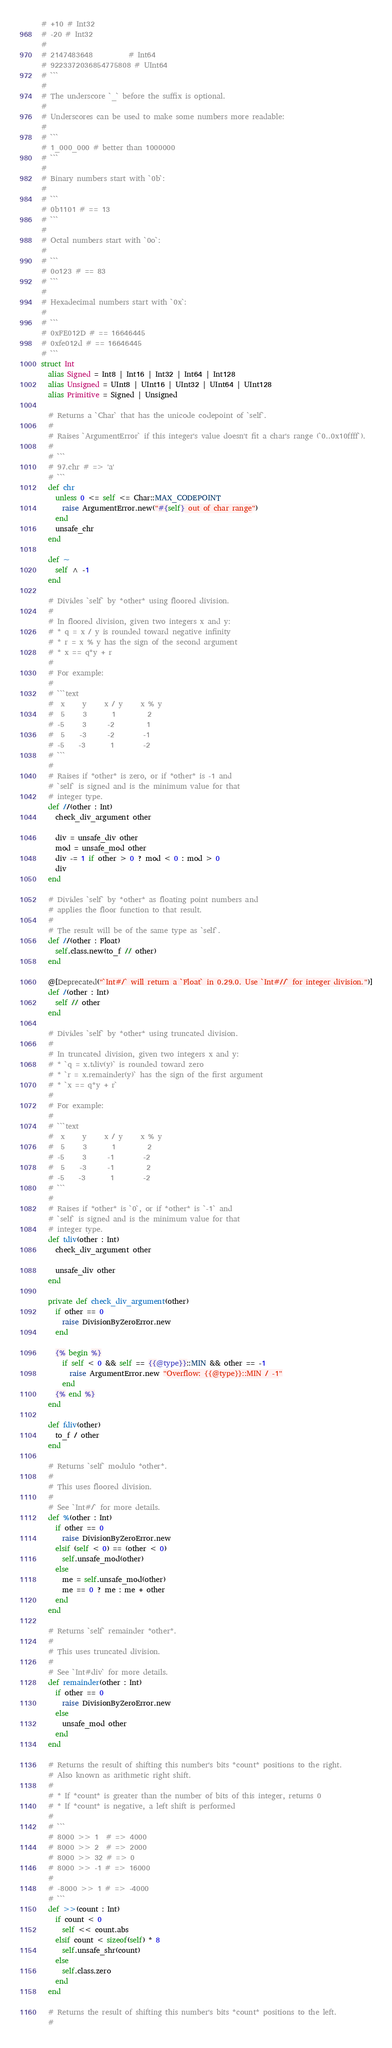Convert code to text. <code><loc_0><loc_0><loc_500><loc_500><_Crystal_># +10 # Int32
# -20 # Int32
#
# 2147483648          # Int64
# 9223372036854775808 # UInt64
# ```
#
# The underscore `_` before the suffix is optional.
#
# Underscores can be used to make some numbers more readable:
#
# ```
# 1_000_000 # better than 1000000
# ```
#
# Binary numbers start with `0b`:
#
# ```
# 0b1101 # == 13
# ```
#
# Octal numbers start with `0o`:
#
# ```
# 0o123 # == 83
# ```
#
# Hexadecimal numbers start with `0x`:
#
# ```
# 0xFE012D # == 16646445
# 0xfe012d # == 16646445
# ```
struct Int
  alias Signed = Int8 | Int16 | Int32 | Int64 | Int128
  alias Unsigned = UInt8 | UInt16 | UInt32 | UInt64 | UInt128
  alias Primitive = Signed | Unsigned

  # Returns a `Char` that has the unicode codepoint of `self`.
  #
  # Raises `ArgumentError` if this integer's value doesn't fit a char's range (`0..0x10ffff`).
  #
  # ```
  # 97.chr # => 'a'
  # ```
  def chr
    unless 0 <= self <= Char::MAX_CODEPOINT
      raise ArgumentError.new("#{self} out of char range")
    end
    unsafe_chr
  end

  def ~
    self ^ -1
  end

  # Divides `self` by *other* using floored division.
  #
  # In floored division, given two integers x and y:
  # * q = x / y is rounded toward negative infinity
  # * r = x % y has the sign of the second argument
  # * x == q*y + r
  #
  # For example:
  #
  # ```text
  #  x     y     x / y     x % y
  #  5     3       1         2
  # -5     3      -2         1
  #  5    -3      -2        -1
  # -5    -3       1        -2
  # ```
  #
  # Raises if *other* is zero, or if *other* is -1 and
  # `self` is signed and is the minimum value for that
  # integer type.
  def //(other : Int)
    check_div_argument other

    div = unsafe_div other
    mod = unsafe_mod other
    div -= 1 if other > 0 ? mod < 0 : mod > 0
    div
  end

  # Divides `self` by *other* as floating point numbers and
  # applies the floor function to that result.
  #
  # The result will be of the same type as `self`.
  def //(other : Float)
    self.class.new(to_f // other)
  end

  @[Deprecated("`Int#/` will return a `Float` in 0.29.0. Use `Int#//` for integer division.")]
  def /(other : Int)
    self // other
  end

  # Divides `self` by *other* using truncated division.
  #
  # In truncated division, given two integers x and y:
  # * `q = x.tdiv(y)` is rounded toward zero
  # * `r = x.remainder(y)` has the sign of the first argument
  # * `x == q*y + r`
  #
  # For example:
  #
  # ```text
  #  x     y     x / y     x % y
  #  5     3       1         2
  # -5     3      -1        -2
  #  5    -3      -1         2
  # -5    -3       1        -2
  # ```
  #
  # Raises if *other* is `0`, or if *other* is `-1` and
  # `self` is signed and is the minimum value for that
  # integer type.
  def tdiv(other : Int)
    check_div_argument other

    unsafe_div other
  end

  private def check_div_argument(other)
    if other == 0
      raise DivisionByZeroError.new
    end

    {% begin %}
      if self < 0 && self == {{@type}}::MIN && other == -1
        raise ArgumentError.new "Overflow: {{@type}}::MIN / -1"
      end
    {% end %}
  end

  def fdiv(other)
    to_f / other
  end

  # Returns `self` modulo *other*.
  #
  # This uses floored division.
  #
  # See `Int#/` for more details.
  def %(other : Int)
    if other == 0
      raise DivisionByZeroError.new
    elsif (self < 0) == (other < 0)
      self.unsafe_mod(other)
    else
      me = self.unsafe_mod(other)
      me == 0 ? me : me + other
    end
  end

  # Returns `self` remainder *other*.
  #
  # This uses truncated division.
  #
  # See `Int#div` for more details.
  def remainder(other : Int)
    if other == 0
      raise DivisionByZeroError.new
    else
      unsafe_mod other
    end
  end

  # Returns the result of shifting this number's bits *count* positions to the right.
  # Also known as arithmetic right shift.
  #
  # * If *count* is greater than the number of bits of this integer, returns 0
  # * If *count* is negative, a left shift is performed
  #
  # ```
  # 8000 >> 1  # => 4000
  # 8000 >> 2  # => 2000
  # 8000 >> 32 # => 0
  # 8000 >> -1 # => 16000
  #
  # -8000 >> 1 # => -4000
  # ```
  def >>(count : Int)
    if count < 0
      self << count.abs
    elsif count < sizeof(self) * 8
      self.unsafe_shr(count)
    else
      self.class.zero
    end
  end

  # Returns the result of shifting this number's bits *count* positions to the left.
  #</code> 